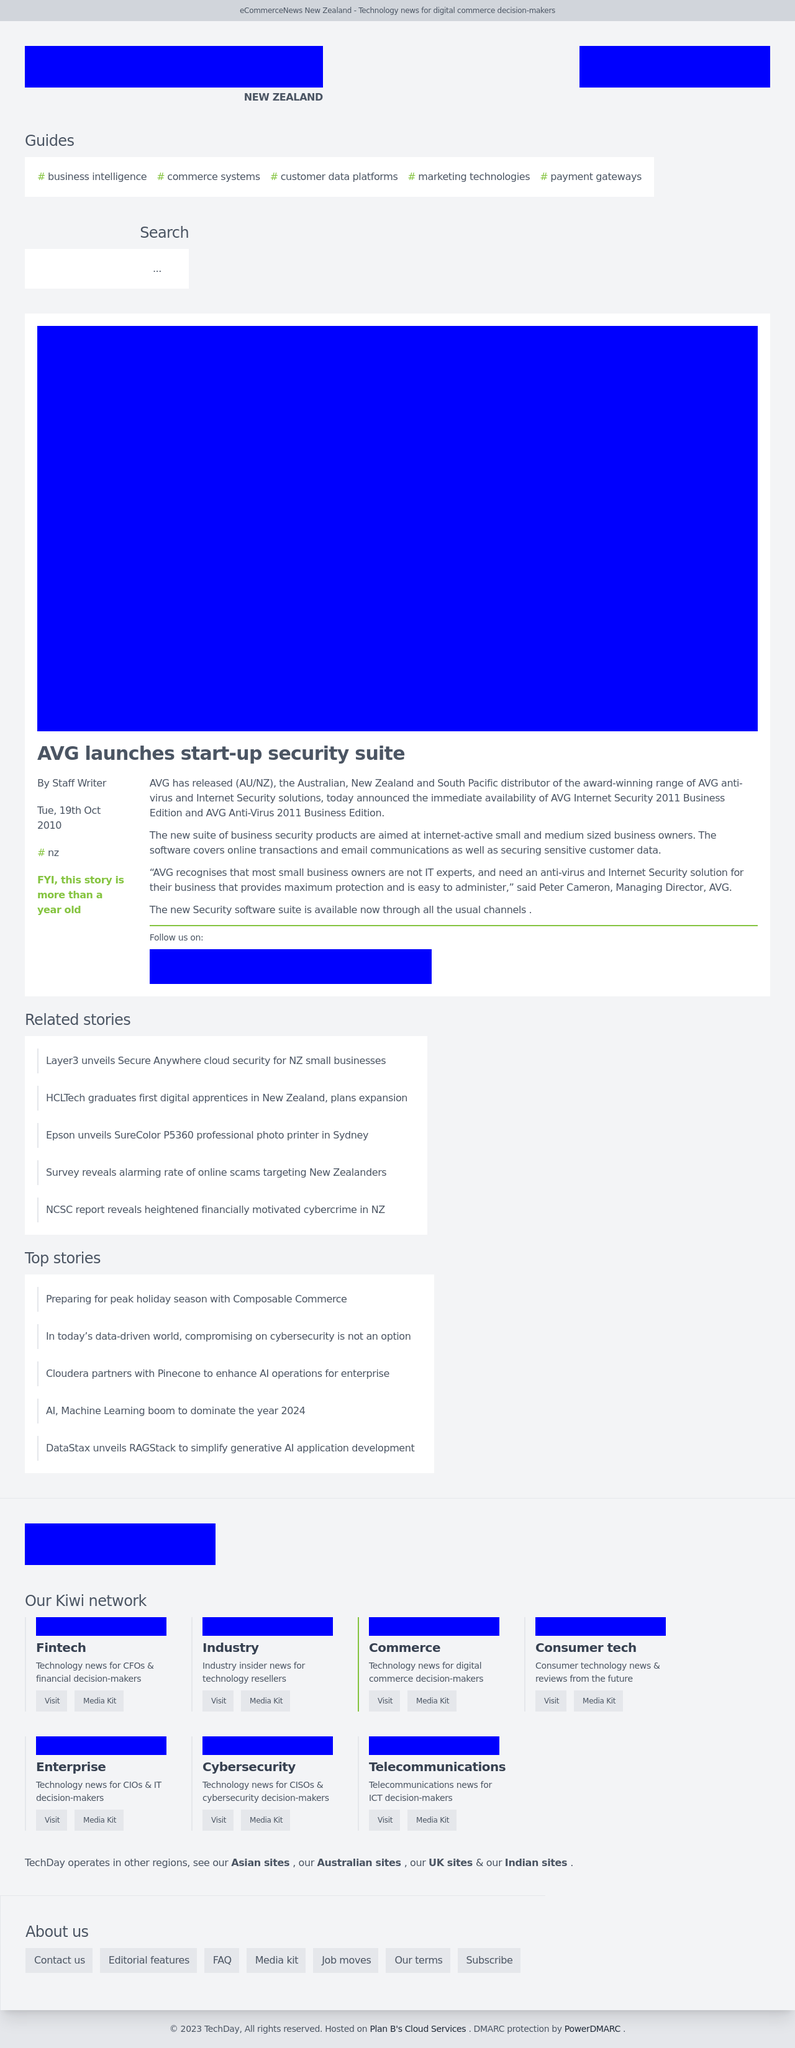Can you describe the theme and layout of the webpage shown in the image? The webpage in the image has a professional and clean layout with a color scheme that mainly revolves around blue tones, signifying trust and reliability. It features a navigation bar, a main headline, categorized content sections, and a responsive search area. This structure indicates a focus on providing information and resources efficiently to visitors, likely in a business or technology news context. 